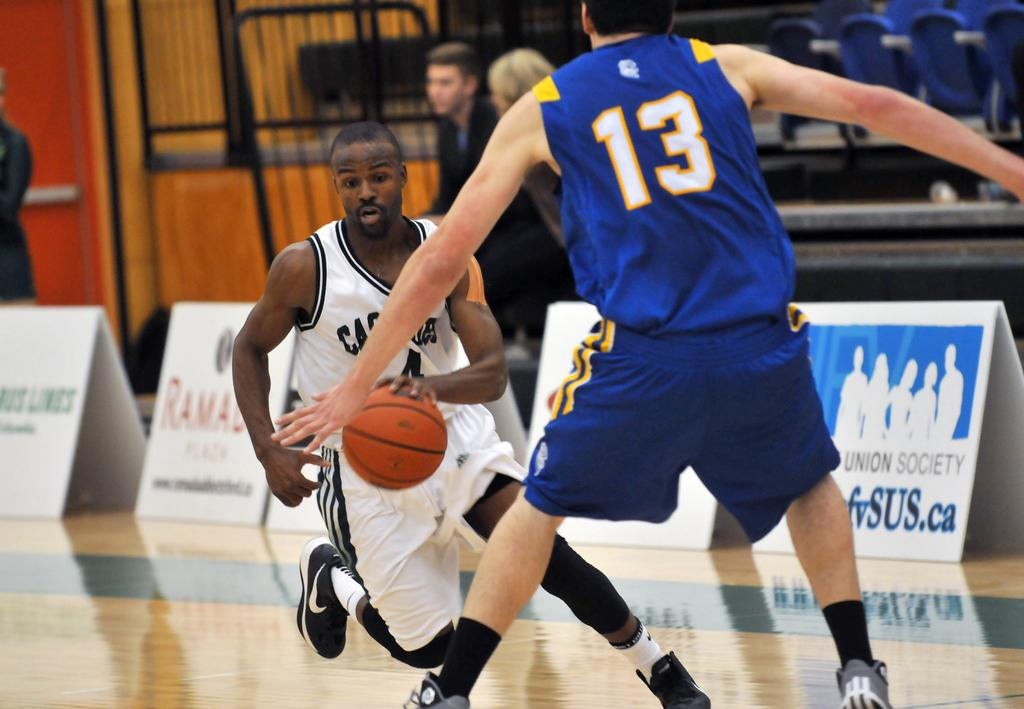Provide a one-sentence caption for the provided image. some people playing basketball and a person wearing the number 13. 